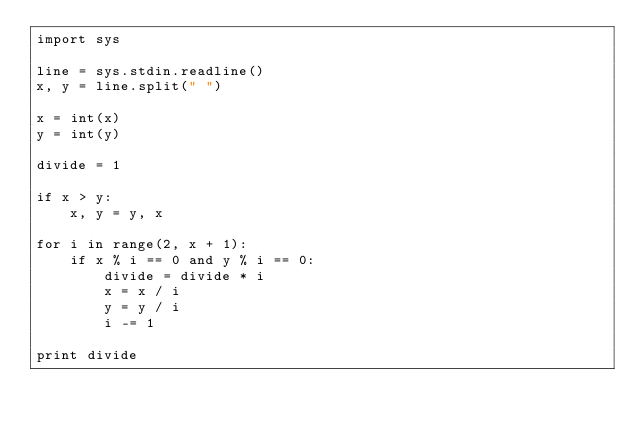<code> <loc_0><loc_0><loc_500><loc_500><_Python_>import sys

line = sys.stdin.readline()
x, y = line.split(" ")

x = int(x)
y = int(y)

divide = 1

if x > y:
    x, y = y, x

for i in range(2, x + 1):
    if x % i == 0 and y % i == 0:
        divide = divide * i
        x = x / i
        y = y / i
        i -= 1

print divide</code> 